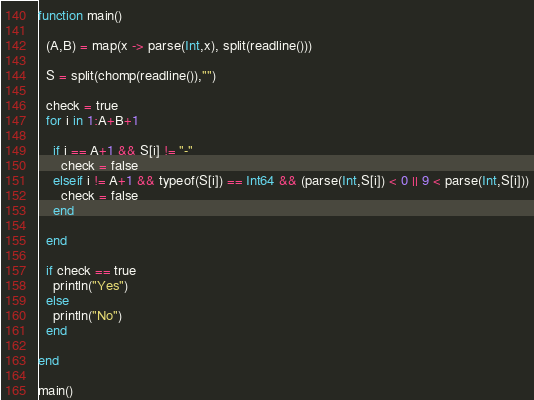Convert code to text. <code><loc_0><loc_0><loc_500><loc_500><_Julia_>function main()
  
  (A,B) = map(x -> parse(Int,x), split(readline()))
  
  S = split(chomp(readline()),"")
  
  check = true
  for i in 1:A+B+1
    
    if i == A+1 && S[i] != "-"
      check = false
    elseif i != A+1 && typeof(S[i]) == Int64 && (parse(Int,S[i]) < 0 || 9 < parse(Int,S[i]))
      check = false
    end
    
  end
  
  if check == true
    println("Yes")
  else
    println("No")
  end
  
end

main()</code> 